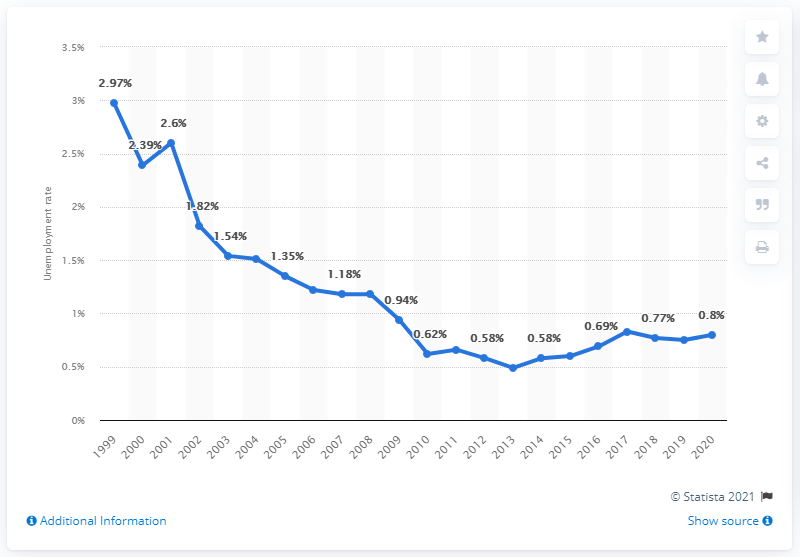Highlight a few significant elements in this photo. In 2020, the unemployment rate in Thailand was 0.8%. 